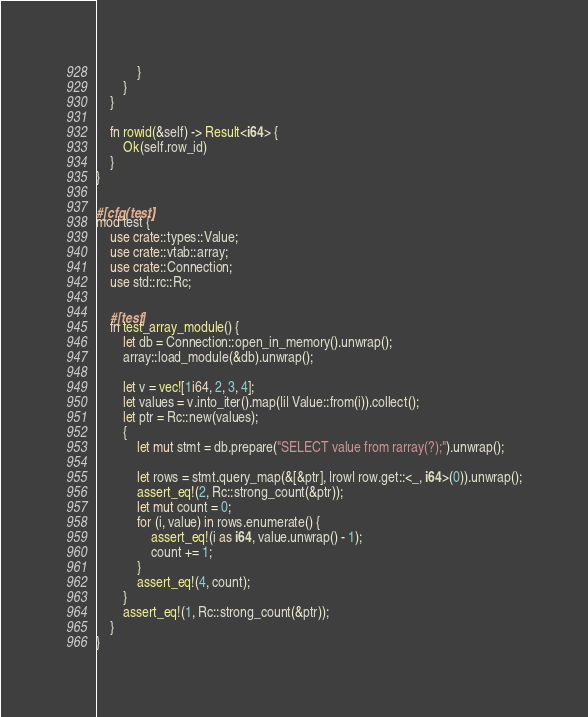<code> <loc_0><loc_0><loc_500><loc_500><_Rust_>            }
        }
    }

    fn rowid(&self) -> Result<i64> {
        Ok(self.row_id)
    }
}

#[cfg(test)]
mod test {
    use crate::types::Value;
    use crate::vtab::array;
    use crate::Connection;
    use std::rc::Rc;

    #[test]
    fn test_array_module() {
        let db = Connection::open_in_memory().unwrap();
        array::load_module(&db).unwrap();

        let v = vec![1i64, 2, 3, 4];
        let values = v.into_iter().map(|i| Value::from(i)).collect();
        let ptr = Rc::new(values);
        {
            let mut stmt = db.prepare("SELECT value from rarray(?);").unwrap();

            let rows = stmt.query_map(&[&ptr], |row| row.get::<_, i64>(0)).unwrap();
            assert_eq!(2, Rc::strong_count(&ptr));
            let mut count = 0;
            for (i, value) in rows.enumerate() {
                assert_eq!(i as i64, value.unwrap() - 1);
                count += 1;
            }
            assert_eq!(4, count);
        }
        assert_eq!(1, Rc::strong_count(&ptr));
    }
}
</code> 